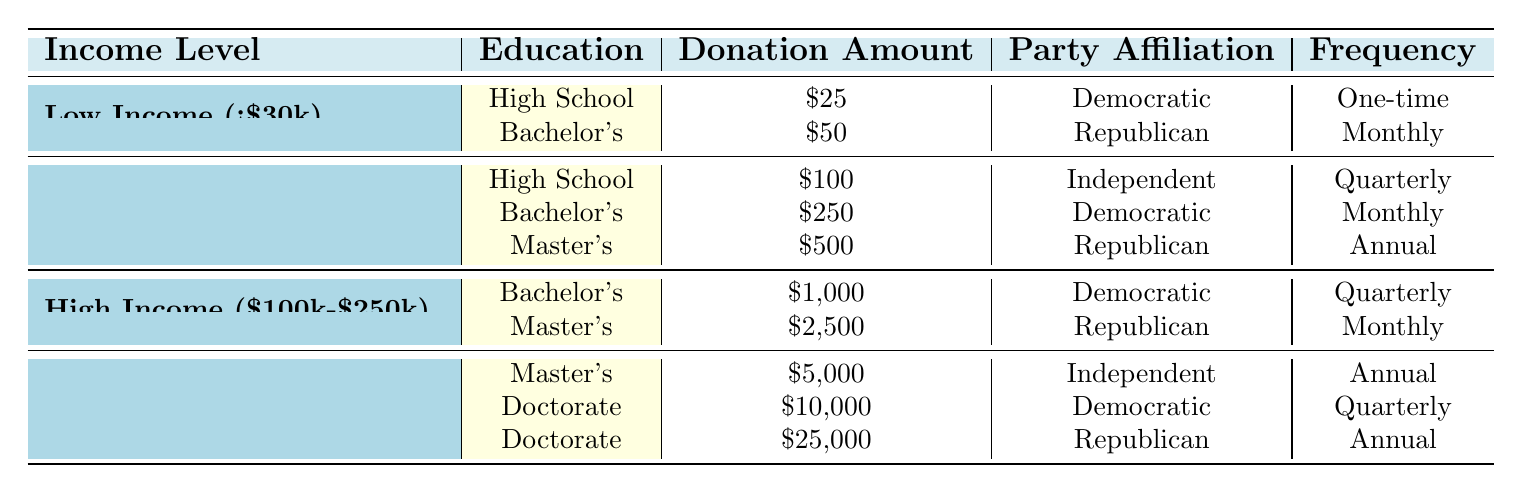What is the highest donation amount recorded in the table? The highest donation amount in the table is $25,000, which is listed under Very High Income (>$250k) for individuals with a Doctorate degree, affiliated with the Republican party and making an annual donation.
Answer: $25,000 Which income level has the lowest overall donation amount? The income level with the lowest overall donation amount is Low Income (<$30k), with donations of $25 and $50, totaling $75.
Answer: Low Income (<$30k) How many unique educational backgrounds are represented at the High Income ($100k-$250k) level? There are two unique educational backgrounds represented at the High Income ($100k-$250k) level: Bachelor's Degree and Master's Degree, each with respective donation amounts.
Answer: 2 Which party affiliation has the highest average donation amount across all income levels? The average donations for party affiliations are calculated as follows: Democratic ($25 + $250 + $1000 + $10,000 = $11,275) over 4 donations = $2,818.75, Republican ($50 + $500 + $2,500 + $25,000 = $28,050) over 4 donations = $7,012.50, Independent ($100 + $5,000 = $5,100) over 2 donations = $2,550. Thus, the Republican party has the highest average donation amount.
Answer: Republican Is there any instance of a monthly donation made by someone with a High School education level? There are no instances of monthly donations made by individuals with a High School education level in the table. The only Low Income instance shows a one-time donation.
Answer: No How does the donation frequency differ among donors with a Bachelor's Degree from the Middle Income group? In the Middle Income group, a Bachelor's Degree donor donates $250 monthly, while a Low Income donor donates $50 monthly. In totality, the only frequency for the Middle Income Bachelor's Degree is "Monthly."
Answer: Monthly What is the total donation amount for individuals with a Master's Degree? The total donation amount for individuals with a Master's Degree from the table is calculated as: $500 (Middle Income) + $2,500 (High Income) + $5,000 (Very High Income) = $8,000.
Answer: $8,000 Which educational background among the Very High Income level has the highest frequency of donation? Among the Very High Income level, the Doctorate degree has a higher frequency of donations: one donation is annual and another is quarterly, thus yielding two instances of noted frequency.
Answer: Doctorate What is the common trend in party affiliation as income level increases? As income level increases, there is a notable trend where the Democratic party is associated with lower and middle incomes, while the Republican party dominates in higher income brackets, indicating potentially different values emphasized by candidates.
Answer: Democratic -> Lower, Republican -> Higher 